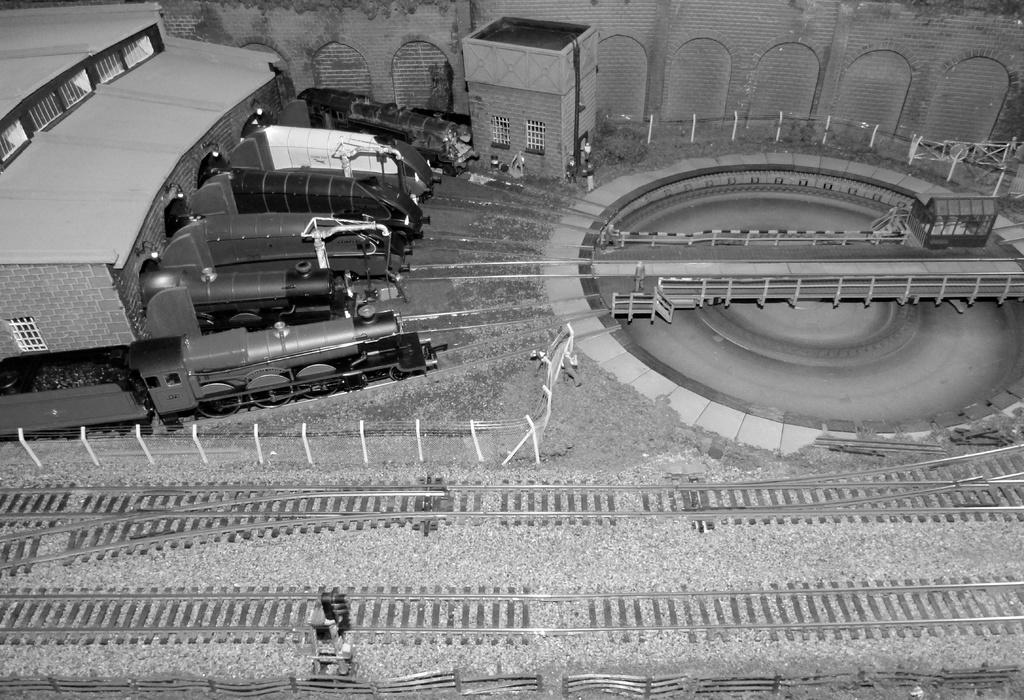What type of surface can be seen in the image? Ground is visible in the image. What transportation-related feature is present in the image? Railway tracks are present in the image. What type of traffic control device is visible in the image? A traffic signal is visible in the image. What type of barrier is present in the image? There is a fence in the image. What mode of transportation can be seen in the image? Trains are present in the image. What type of shelter is visible in the image? Shelters are visible in the image. Can you describe any unspecified objects in the image? There are some unspecified objects in the image. What can be seen in the background of the image? There is a wall in the background of the image. Where are the balls being used in the image? There are no balls present in the image. What type of farming equipment is visible in the image? There is no farming equipment, such as a plough, present in the image. 